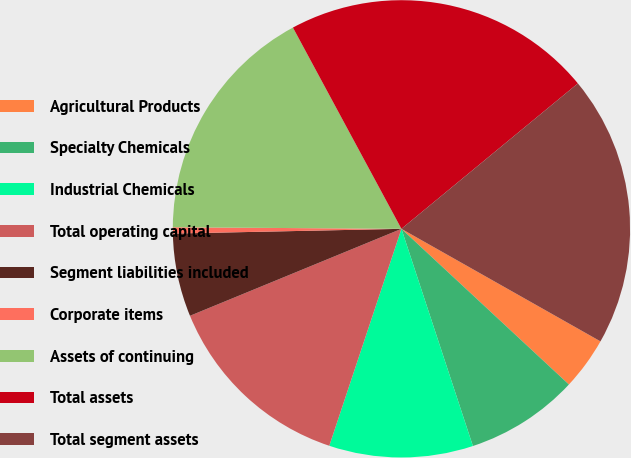Convert chart. <chart><loc_0><loc_0><loc_500><loc_500><pie_chart><fcel>Agricultural Products<fcel>Specialty Chemicals<fcel>Industrial Chemicals<fcel>Total operating capital<fcel>Segment liabilities included<fcel>Corporate items<fcel>Assets of continuing<fcel>Total assets<fcel>Total segment assets<nl><fcel>3.73%<fcel>8.02%<fcel>10.17%<fcel>13.68%<fcel>5.88%<fcel>0.44%<fcel>17.02%<fcel>21.9%<fcel>19.16%<nl></chart> 